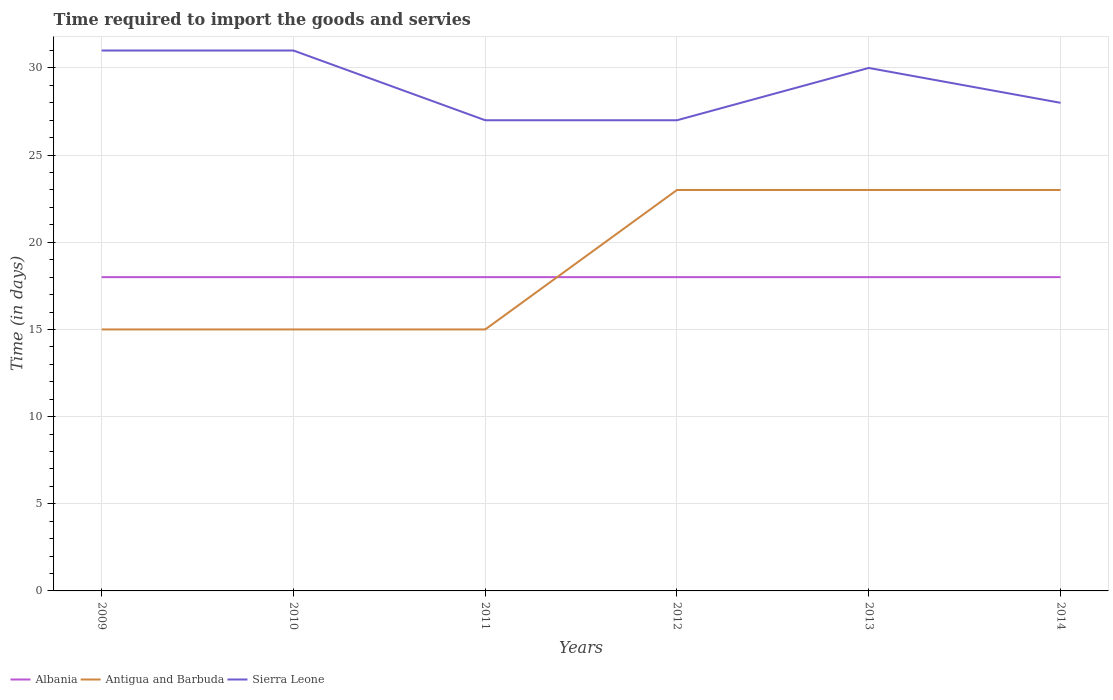Is the number of lines equal to the number of legend labels?
Offer a very short reply. Yes. Across all years, what is the maximum number of days required to import the goods and services in Sierra Leone?
Provide a succinct answer. 27. In which year was the number of days required to import the goods and services in Sierra Leone maximum?
Offer a very short reply. 2011. What is the total number of days required to import the goods and services in Sierra Leone in the graph?
Ensure brevity in your answer.  4. What is the difference between the highest and the second highest number of days required to import the goods and services in Albania?
Keep it short and to the point. 0. What is the difference between the highest and the lowest number of days required to import the goods and services in Albania?
Your response must be concise. 0. Is the number of days required to import the goods and services in Albania strictly greater than the number of days required to import the goods and services in Antigua and Barbuda over the years?
Give a very brief answer. No. How many lines are there?
Offer a terse response. 3. What is the difference between two consecutive major ticks on the Y-axis?
Keep it short and to the point. 5. Are the values on the major ticks of Y-axis written in scientific E-notation?
Ensure brevity in your answer.  No. Where does the legend appear in the graph?
Your answer should be very brief. Bottom left. How are the legend labels stacked?
Make the answer very short. Horizontal. What is the title of the graph?
Provide a short and direct response. Time required to import the goods and servies. What is the label or title of the X-axis?
Offer a terse response. Years. What is the label or title of the Y-axis?
Your response must be concise. Time (in days). What is the Time (in days) of Albania in 2009?
Your answer should be compact. 18. What is the Time (in days) in Antigua and Barbuda in 2009?
Provide a succinct answer. 15. What is the Time (in days) of Antigua and Barbuda in 2011?
Offer a very short reply. 15. What is the Time (in days) in Albania in 2013?
Your response must be concise. 18. What is the Time (in days) in Antigua and Barbuda in 2013?
Make the answer very short. 23. What is the Time (in days) in Sierra Leone in 2014?
Your answer should be compact. 28. Across all years, what is the maximum Time (in days) of Albania?
Keep it short and to the point. 18. Across all years, what is the minimum Time (in days) of Albania?
Make the answer very short. 18. Across all years, what is the minimum Time (in days) of Antigua and Barbuda?
Your answer should be very brief. 15. What is the total Time (in days) in Albania in the graph?
Your answer should be compact. 108. What is the total Time (in days) of Antigua and Barbuda in the graph?
Ensure brevity in your answer.  114. What is the total Time (in days) of Sierra Leone in the graph?
Offer a very short reply. 174. What is the difference between the Time (in days) in Albania in 2009 and that in 2010?
Provide a succinct answer. 0. What is the difference between the Time (in days) of Sierra Leone in 2009 and that in 2010?
Your answer should be compact. 0. What is the difference between the Time (in days) of Albania in 2009 and that in 2012?
Offer a very short reply. 0. What is the difference between the Time (in days) of Antigua and Barbuda in 2009 and that in 2012?
Make the answer very short. -8. What is the difference between the Time (in days) in Sierra Leone in 2009 and that in 2012?
Offer a terse response. 4. What is the difference between the Time (in days) of Albania in 2009 and that in 2013?
Give a very brief answer. 0. What is the difference between the Time (in days) of Sierra Leone in 2009 and that in 2013?
Offer a very short reply. 1. What is the difference between the Time (in days) of Sierra Leone in 2009 and that in 2014?
Make the answer very short. 3. What is the difference between the Time (in days) of Albania in 2010 and that in 2011?
Your response must be concise. 0. What is the difference between the Time (in days) of Sierra Leone in 2010 and that in 2011?
Make the answer very short. 4. What is the difference between the Time (in days) of Antigua and Barbuda in 2010 and that in 2012?
Your answer should be compact. -8. What is the difference between the Time (in days) in Antigua and Barbuda in 2010 and that in 2013?
Provide a succinct answer. -8. What is the difference between the Time (in days) of Sierra Leone in 2010 and that in 2013?
Give a very brief answer. 1. What is the difference between the Time (in days) of Albania in 2010 and that in 2014?
Offer a very short reply. 0. What is the difference between the Time (in days) of Antigua and Barbuda in 2010 and that in 2014?
Offer a very short reply. -8. What is the difference between the Time (in days) of Sierra Leone in 2010 and that in 2014?
Your answer should be compact. 3. What is the difference between the Time (in days) of Albania in 2011 and that in 2013?
Give a very brief answer. 0. What is the difference between the Time (in days) in Sierra Leone in 2011 and that in 2013?
Give a very brief answer. -3. What is the difference between the Time (in days) of Sierra Leone in 2011 and that in 2014?
Your answer should be compact. -1. What is the difference between the Time (in days) of Albania in 2012 and that in 2013?
Offer a very short reply. 0. What is the difference between the Time (in days) in Albania in 2012 and that in 2014?
Offer a terse response. 0. What is the difference between the Time (in days) in Antigua and Barbuda in 2012 and that in 2014?
Offer a terse response. 0. What is the difference between the Time (in days) of Sierra Leone in 2012 and that in 2014?
Give a very brief answer. -1. What is the difference between the Time (in days) of Sierra Leone in 2013 and that in 2014?
Your response must be concise. 2. What is the difference between the Time (in days) in Albania in 2009 and the Time (in days) in Antigua and Barbuda in 2010?
Ensure brevity in your answer.  3. What is the difference between the Time (in days) in Albania in 2009 and the Time (in days) in Antigua and Barbuda in 2011?
Ensure brevity in your answer.  3. What is the difference between the Time (in days) of Albania in 2009 and the Time (in days) of Antigua and Barbuda in 2012?
Make the answer very short. -5. What is the difference between the Time (in days) of Albania in 2009 and the Time (in days) of Sierra Leone in 2012?
Make the answer very short. -9. What is the difference between the Time (in days) of Albania in 2009 and the Time (in days) of Sierra Leone in 2013?
Your answer should be compact. -12. What is the difference between the Time (in days) in Antigua and Barbuda in 2009 and the Time (in days) in Sierra Leone in 2013?
Provide a short and direct response. -15. What is the difference between the Time (in days) of Albania in 2009 and the Time (in days) of Sierra Leone in 2014?
Your response must be concise. -10. What is the difference between the Time (in days) in Antigua and Barbuda in 2009 and the Time (in days) in Sierra Leone in 2014?
Make the answer very short. -13. What is the difference between the Time (in days) of Albania in 2010 and the Time (in days) of Sierra Leone in 2011?
Give a very brief answer. -9. What is the difference between the Time (in days) of Antigua and Barbuda in 2010 and the Time (in days) of Sierra Leone in 2011?
Ensure brevity in your answer.  -12. What is the difference between the Time (in days) of Albania in 2010 and the Time (in days) of Antigua and Barbuda in 2012?
Offer a terse response. -5. What is the difference between the Time (in days) in Antigua and Barbuda in 2010 and the Time (in days) in Sierra Leone in 2014?
Make the answer very short. -13. What is the difference between the Time (in days) of Albania in 2011 and the Time (in days) of Antigua and Barbuda in 2012?
Give a very brief answer. -5. What is the difference between the Time (in days) in Albania in 2011 and the Time (in days) in Sierra Leone in 2012?
Make the answer very short. -9. What is the difference between the Time (in days) in Antigua and Barbuda in 2011 and the Time (in days) in Sierra Leone in 2012?
Ensure brevity in your answer.  -12. What is the difference between the Time (in days) of Albania in 2011 and the Time (in days) of Antigua and Barbuda in 2013?
Make the answer very short. -5. What is the difference between the Time (in days) of Albania in 2011 and the Time (in days) of Sierra Leone in 2013?
Keep it short and to the point. -12. What is the difference between the Time (in days) in Antigua and Barbuda in 2011 and the Time (in days) in Sierra Leone in 2013?
Give a very brief answer. -15. What is the difference between the Time (in days) of Albania in 2011 and the Time (in days) of Sierra Leone in 2014?
Offer a terse response. -10. What is the difference between the Time (in days) in Antigua and Barbuda in 2011 and the Time (in days) in Sierra Leone in 2014?
Provide a succinct answer. -13. What is the difference between the Time (in days) of Albania in 2012 and the Time (in days) of Sierra Leone in 2013?
Make the answer very short. -12. What is the difference between the Time (in days) of Albania in 2012 and the Time (in days) of Antigua and Barbuda in 2014?
Your response must be concise. -5. What is the difference between the Time (in days) of Albania in 2012 and the Time (in days) of Sierra Leone in 2014?
Your response must be concise. -10. What is the difference between the Time (in days) in Albania in 2013 and the Time (in days) in Antigua and Barbuda in 2014?
Offer a terse response. -5. What is the difference between the Time (in days) of Albania in 2013 and the Time (in days) of Sierra Leone in 2014?
Offer a terse response. -10. What is the average Time (in days) in Albania per year?
Offer a very short reply. 18. What is the average Time (in days) of Antigua and Barbuda per year?
Keep it short and to the point. 19. In the year 2009, what is the difference between the Time (in days) in Albania and Time (in days) in Antigua and Barbuda?
Provide a succinct answer. 3. In the year 2009, what is the difference between the Time (in days) of Albania and Time (in days) of Sierra Leone?
Your answer should be compact. -13. In the year 2009, what is the difference between the Time (in days) of Antigua and Barbuda and Time (in days) of Sierra Leone?
Offer a terse response. -16. In the year 2010, what is the difference between the Time (in days) of Albania and Time (in days) of Antigua and Barbuda?
Offer a terse response. 3. In the year 2010, what is the difference between the Time (in days) in Albania and Time (in days) in Sierra Leone?
Offer a terse response. -13. In the year 2011, what is the difference between the Time (in days) in Albania and Time (in days) in Antigua and Barbuda?
Provide a short and direct response. 3. In the year 2011, what is the difference between the Time (in days) in Antigua and Barbuda and Time (in days) in Sierra Leone?
Provide a succinct answer. -12. In the year 2012, what is the difference between the Time (in days) in Albania and Time (in days) in Antigua and Barbuda?
Ensure brevity in your answer.  -5. In the year 2014, what is the difference between the Time (in days) in Albania and Time (in days) in Sierra Leone?
Ensure brevity in your answer.  -10. In the year 2014, what is the difference between the Time (in days) of Antigua and Barbuda and Time (in days) of Sierra Leone?
Your answer should be very brief. -5. What is the ratio of the Time (in days) in Sierra Leone in 2009 to that in 2011?
Offer a terse response. 1.15. What is the ratio of the Time (in days) in Antigua and Barbuda in 2009 to that in 2012?
Make the answer very short. 0.65. What is the ratio of the Time (in days) in Sierra Leone in 2009 to that in 2012?
Make the answer very short. 1.15. What is the ratio of the Time (in days) in Antigua and Barbuda in 2009 to that in 2013?
Your response must be concise. 0.65. What is the ratio of the Time (in days) of Sierra Leone in 2009 to that in 2013?
Your answer should be compact. 1.03. What is the ratio of the Time (in days) in Albania in 2009 to that in 2014?
Offer a terse response. 1. What is the ratio of the Time (in days) of Antigua and Barbuda in 2009 to that in 2014?
Offer a very short reply. 0.65. What is the ratio of the Time (in days) of Sierra Leone in 2009 to that in 2014?
Offer a terse response. 1.11. What is the ratio of the Time (in days) of Sierra Leone in 2010 to that in 2011?
Offer a terse response. 1.15. What is the ratio of the Time (in days) of Antigua and Barbuda in 2010 to that in 2012?
Offer a terse response. 0.65. What is the ratio of the Time (in days) of Sierra Leone in 2010 to that in 2012?
Keep it short and to the point. 1.15. What is the ratio of the Time (in days) in Albania in 2010 to that in 2013?
Make the answer very short. 1. What is the ratio of the Time (in days) in Antigua and Barbuda in 2010 to that in 2013?
Keep it short and to the point. 0.65. What is the ratio of the Time (in days) in Albania in 2010 to that in 2014?
Provide a short and direct response. 1. What is the ratio of the Time (in days) of Antigua and Barbuda in 2010 to that in 2014?
Offer a very short reply. 0.65. What is the ratio of the Time (in days) in Sierra Leone in 2010 to that in 2014?
Provide a succinct answer. 1.11. What is the ratio of the Time (in days) of Antigua and Barbuda in 2011 to that in 2012?
Provide a succinct answer. 0.65. What is the ratio of the Time (in days) of Antigua and Barbuda in 2011 to that in 2013?
Ensure brevity in your answer.  0.65. What is the ratio of the Time (in days) of Sierra Leone in 2011 to that in 2013?
Make the answer very short. 0.9. What is the ratio of the Time (in days) of Albania in 2011 to that in 2014?
Provide a succinct answer. 1. What is the ratio of the Time (in days) in Antigua and Barbuda in 2011 to that in 2014?
Your answer should be very brief. 0.65. What is the ratio of the Time (in days) in Sierra Leone in 2011 to that in 2014?
Make the answer very short. 0.96. What is the ratio of the Time (in days) in Albania in 2012 to that in 2013?
Keep it short and to the point. 1. What is the ratio of the Time (in days) of Antigua and Barbuda in 2012 to that in 2013?
Keep it short and to the point. 1. What is the ratio of the Time (in days) in Sierra Leone in 2012 to that in 2014?
Provide a short and direct response. 0.96. What is the ratio of the Time (in days) of Albania in 2013 to that in 2014?
Make the answer very short. 1. What is the ratio of the Time (in days) in Sierra Leone in 2013 to that in 2014?
Your answer should be very brief. 1.07. What is the difference between the highest and the second highest Time (in days) of Albania?
Keep it short and to the point. 0. What is the difference between the highest and the second highest Time (in days) in Antigua and Barbuda?
Ensure brevity in your answer.  0. What is the difference between the highest and the second highest Time (in days) in Sierra Leone?
Keep it short and to the point. 0. What is the difference between the highest and the lowest Time (in days) of Albania?
Provide a succinct answer. 0. What is the difference between the highest and the lowest Time (in days) of Antigua and Barbuda?
Ensure brevity in your answer.  8. 